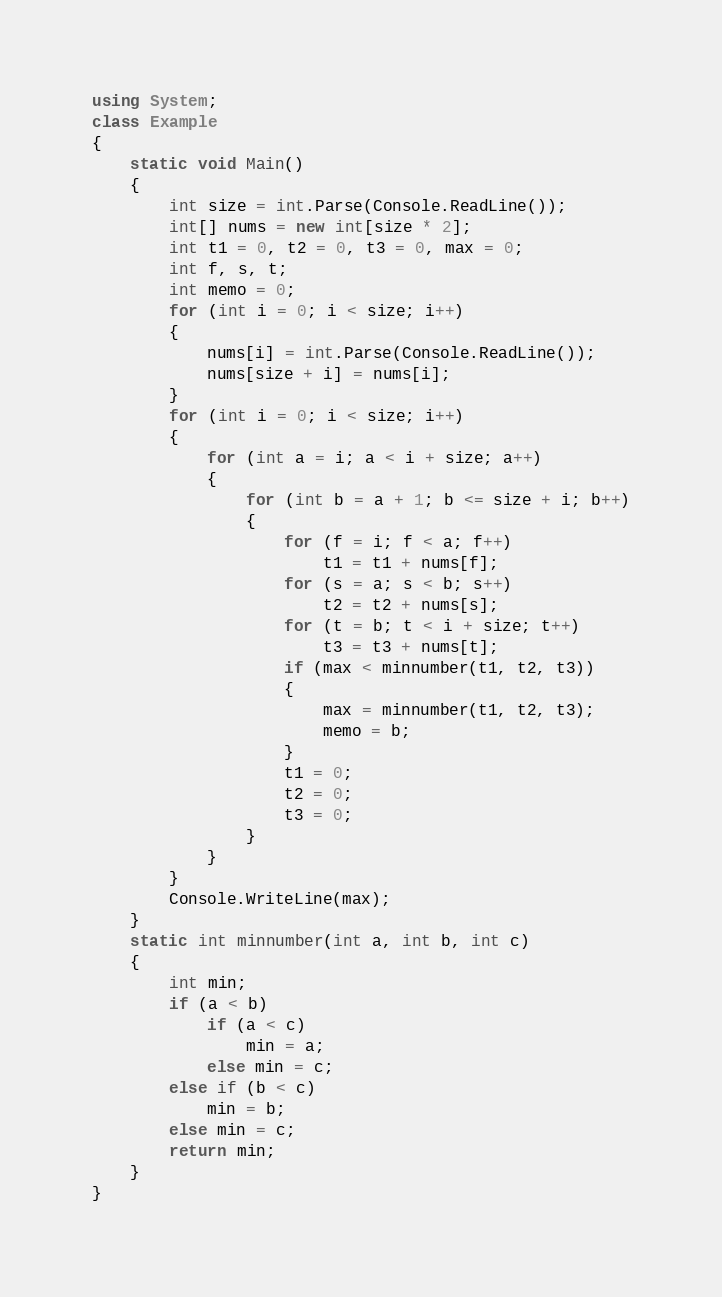Convert code to text. <code><loc_0><loc_0><loc_500><loc_500><_C#_>using System;
class Example
{
    static void Main()
    {
        int size = int.Parse(Console.ReadLine());
        int[] nums = new int[size * 2];
        int t1 = 0, t2 = 0, t3 = 0, max = 0;
        int f, s, t;
        int memo = 0;
        for (int i = 0; i < size; i++)
        {
            nums[i] = int.Parse(Console.ReadLine());
            nums[size + i] = nums[i];
        }
        for (int i = 0; i < size; i++)
        {
            for (int a = i; a < i + size; a++)
            {
                for (int b = a + 1; b <= size + i; b++)
                {
                    for (f = i; f < a; f++)
                        t1 = t1 + nums[f];
                    for (s = a; s < b; s++)
                        t2 = t2 + nums[s];
                    for (t = b; t < i + size; t++)
                        t3 = t3 + nums[t];
                    if (max < minnumber(t1, t2, t3))
                    {
                        max = minnumber(t1, t2, t3);
                        memo = b;
                    }
                    t1 = 0;
                    t2 = 0;
                    t3 = 0;
                }
            }
        }
        Console.WriteLine(max);
    }
    static int minnumber(int a, int b, int c)
    {
        int min;
        if (a < b)
            if (a < c)
                min = a;
            else min = c;
        else if (b < c)
            min = b;
        else min = c;
        return min;
    }
}</code> 